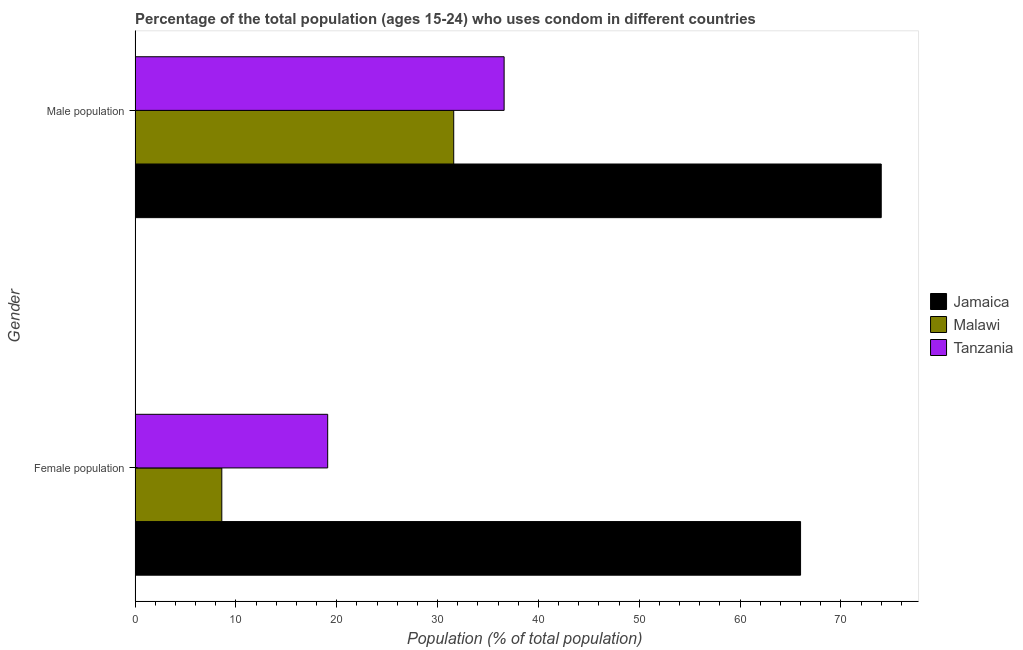How many groups of bars are there?
Offer a very short reply. 2. Are the number of bars per tick equal to the number of legend labels?
Ensure brevity in your answer.  Yes. What is the label of the 2nd group of bars from the top?
Your answer should be very brief. Female population. Across all countries, what is the minimum female population?
Ensure brevity in your answer.  8.6. In which country was the female population maximum?
Keep it short and to the point. Jamaica. In which country was the male population minimum?
Offer a very short reply. Malawi. What is the total female population in the graph?
Ensure brevity in your answer.  93.7. What is the difference between the female population in Malawi and that in Tanzania?
Provide a succinct answer. -10.5. What is the difference between the female population in Malawi and the male population in Jamaica?
Keep it short and to the point. -65.4. What is the average male population per country?
Ensure brevity in your answer.  47.4. What is the difference between the male population and female population in Tanzania?
Keep it short and to the point. 17.5. In how many countries, is the female population greater than 60 %?
Provide a succinct answer. 1. What is the ratio of the male population in Malawi to that in Jamaica?
Provide a short and direct response. 0.43. In how many countries, is the male population greater than the average male population taken over all countries?
Provide a short and direct response. 1. What does the 3rd bar from the top in Female population represents?
Keep it short and to the point. Jamaica. What does the 3rd bar from the bottom in Male population represents?
Provide a short and direct response. Tanzania. Are all the bars in the graph horizontal?
Ensure brevity in your answer.  Yes. What is the difference between two consecutive major ticks on the X-axis?
Provide a short and direct response. 10. Does the graph contain grids?
Ensure brevity in your answer.  No. How many legend labels are there?
Keep it short and to the point. 3. How are the legend labels stacked?
Provide a short and direct response. Vertical. What is the title of the graph?
Offer a terse response. Percentage of the total population (ages 15-24) who uses condom in different countries. Does "Ecuador" appear as one of the legend labels in the graph?
Your answer should be very brief. No. What is the label or title of the X-axis?
Give a very brief answer. Population (% of total population) . What is the Population (% of total population)  in Malawi in Male population?
Your answer should be very brief. 31.6. What is the Population (% of total population)  in Tanzania in Male population?
Your response must be concise. 36.6. Across all Gender, what is the maximum Population (% of total population)  of Jamaica?
Offer a very short reply. 74. Across all Gender, what is the maximum Population (% of total population)  in Malawi?
Make the answer very short. 31.6. Across all Gender, what is the maximum Population (% of total population)  of Tanzania?
Offer a terse response. 36.6. Across all Gender, what is the minimum Population (% of total population)  of Jamaica?
Provide a succinct answer. 66. Across all Gender, what is the minimum Population (% of total population)  in Malawi?
Your response must be concise. 8.6. Across all Gender, what is the minimum Population (% of total population)  in Tanzania?
Your answer should be compact. 19.1. What is the total Population (% of total population)  of Jamaica in the graph?
Ensure brevity in your answer.  140. What is the total Population (% of total population)  in Malawi in the graph?
Offer a terse response. 40.2. What is the total Population (% of total population)  of Tanzania in the graph?
Give a very brief answer. 55.7. What is the difference between the Population (% of total population)  of Tanzania in Female population and that in Male population?
Offer a terse response. -17.5. What is the difference between the Population (% of total population)  in Jamaica in Female population and the Population (% of total population)  in Malawi in Male population?
Provide a succinct answer. 34.4. What is the difference between the Population (% of total population)  of Jamaica in Female population and the Population (% of total population)  of Tanzania in Male population?
Offer a terse response. 29.4. What is the average Population (% of total population)  of Jamaica per Gender?
Your response must be concise. 70. What is the average Population (% of total population)  in Malawi per Gender?
Make the answer very short. 20.1. What is the average Population (% of total population)  in Tanzania per Gender?
Give a very brief answer. 27.85. What is the difference between the Population (% of total population)  of Jamaica and Population (% of total population)  of Malawi in Female population?
Your response must be concise. 57.4. What is the difference between the Population (% of total population)  of Jamaica and Population (% of total population)  of Tanzania in Female population?
Offer a very short reply. 46.9. What is the difference between the Population (% of total population)  of Malawi and Population (% of total population)  of Tanzania in Female population?
Offer a very short reply. -10.5. What is the difference between the Population (% of total population)  of Jamaica and Population (% of total population)  of Malawi in Male population?
Make the answer very short. 42.4. What is the difference between the Population (% of total population)  of Jamaica and Population (% of total population)  of Tanzania in Male population?
Your answer should be compact. 37.4. What is the difference between the Population (% of total population)  in Malawi and Population (% of total population)  in Tanzania in Male population?
Make the answer very short. -5. What is the ratio of the Population (% of total population)  of Jamaica in Female population to that in Male population?
Ensure brevity in your answer.  0.89. What is the ratio of the Population (% of total population)  in Malawi in Female population to that in Male population?
Your answer should be compact. 0.27. What is the ratio of the Population (% of total population)  of Tanzania in Female population to that in Male population?
Provide a short and direct response. 0.52. What is the difference between the highest and the second highest Population (% of total population)  of Tanzania?
Your answer should be very brief. 17.5. What is the difference between the highest and the lowest Population (% of total population)  in Tanzania?
Your answer should be very brief. 17.5. 